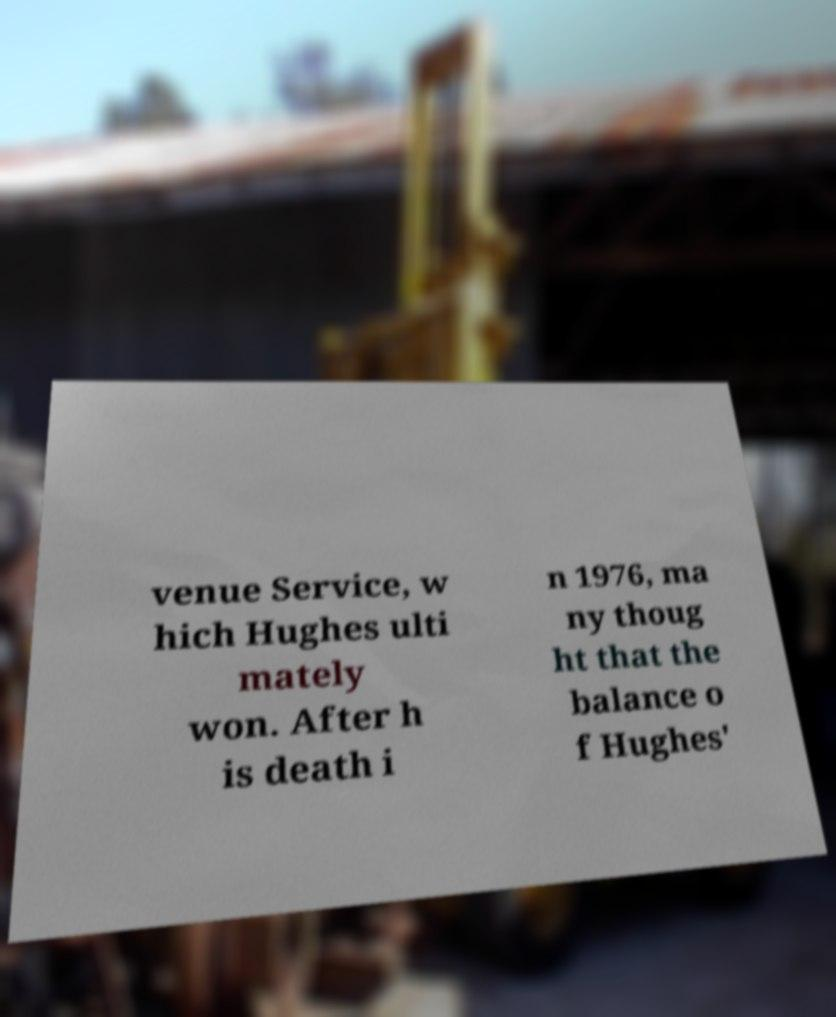Could you assist in decoding the text presented in this image and type it out clearly? venue Service, w hich Hughes ulti mately won. After h is death i n 1976, ma ny thoug ht that the balance o f Hughes' 